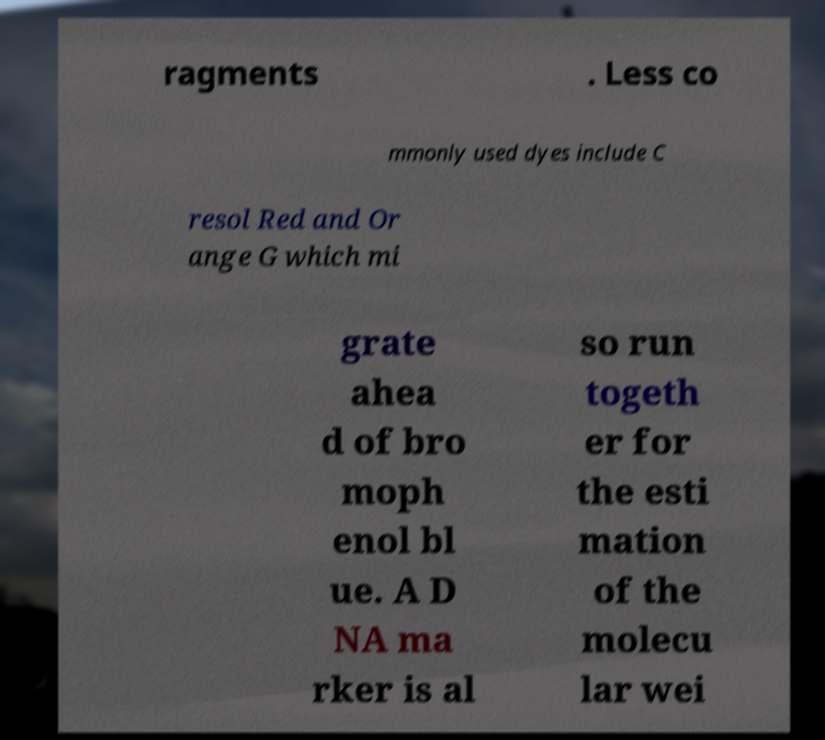For documentation purposes, I need the text within this image transcribed. Could you provide that? ragments . Less co mmonly used dyes include C resol Red and Or ange G which mi grate ahea d of bro moph enol bl ue. A D NA ma rker is al so run togeth er for the esti mation of the molecu lar wei 